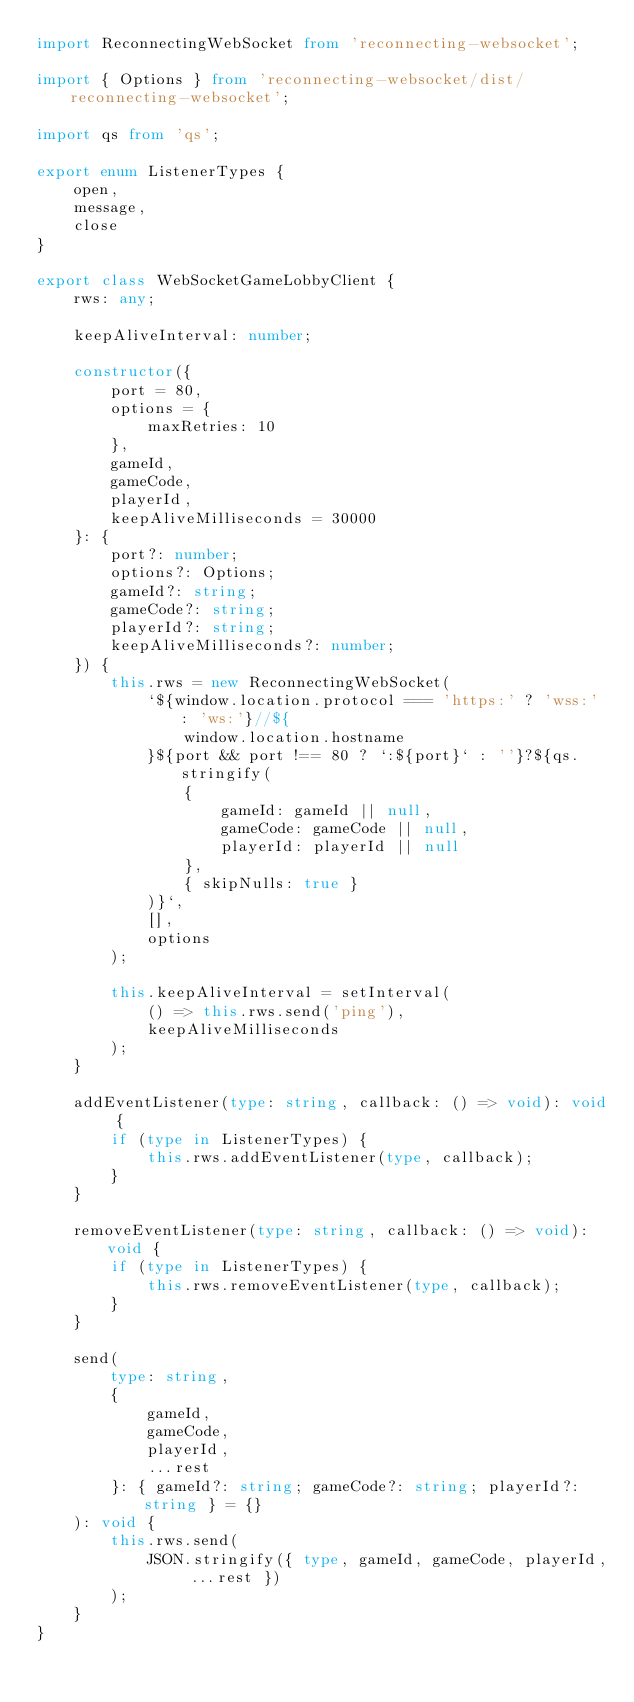<code> <loc_0><loc_0><loc_500><loc_500><_TypeScript_>import ReconnectingWebSocket from 'reconnecting-websocket';

import { Options } from 'reconnecting-websocket/dist/reconnecting-websocket';

import qs from 'qs';

export enum ListenerTypes {
    open,
    message,
    close
}

export class WebSocketGameLobbyClient {
    rws: any;

    keepAliveInterval: number;

    constructor({
        port = 80,
        options = {
            maxRetries: 10
        },
        gameId,
        gameCode,
        playerId,
        keepAliveMilliseconds = 30000
    }: {
        port?: number;
        options?: Options;
        gameId?: string;
        gameCode?: string;
        playerId?: string;
        keepAliveMilliseconds?: number;
    }) {
        this.rws = new ReconnectingWebSocket(
            `${window.location.protocol === 'https:' ? 'wss:' : 'ws:'}//${
                window.location.hostname
            }${port && port !== 80 ? `:${port}` : ''}?${qs.stringify(
                {
                    gameId: gameId || null,
                    gameCode: gameCode || null,
                    playerId: playerId || null
                },
                { skipNulls: true }
            )}`,
            [],
            options
        );

        this.keepAliveInterval = setInterval(
            () => this.rws.send('ping'),
            keepAliveMilliseconds
        );
    }

    addEventListener(type: string, callback: () => void): void {
        if (type in ListenerTypes) {
            this.rws.addEventListener(type, callback);
        }
    }

    removeEventListener(type: string, callback: () => void): void {
        if (type in ListenerTypes) {
            this.rws.removeEventListener(type, callback);
        }
    }

    send(
        type: string,
        {
            gameId,
            gameCode,
            playerId,
            ...rest
        }: { gameId?: string; gameCode?: string; playerId?: string } = {}
    ): void {
        this.rws.send(
            JSON.stringify({ type, gameId, gameCode, playerId, ...rest })
        );
    }
}
</code> 